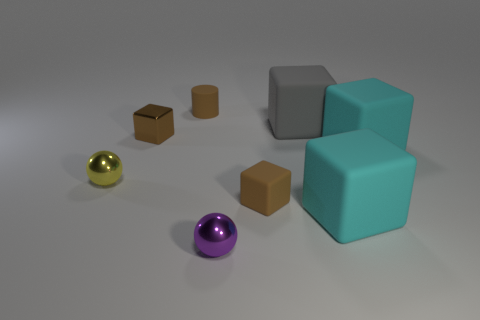Subtract all metallic cubes. How many cubes are left? 4 Subtract all gray cubes. How many cubes are left? 4 Subtract all blue cubes. Subtract all brown cylinders. How many cubes are left? 5 Add 2 brown metallic things. How many objects exist? 10 Subtract all cubes. How many objects are left? 3 Add 3 gray matte things. How many gray matte things exist? 4 Subtract 1 yellow balls. How many objects are left? 7 Subtract all yellow shiny spheres. Subtract all yellow shiny balls. How many objects are left? 6 Add 5 yellow metal things. How many yellow metal things are left? 6 